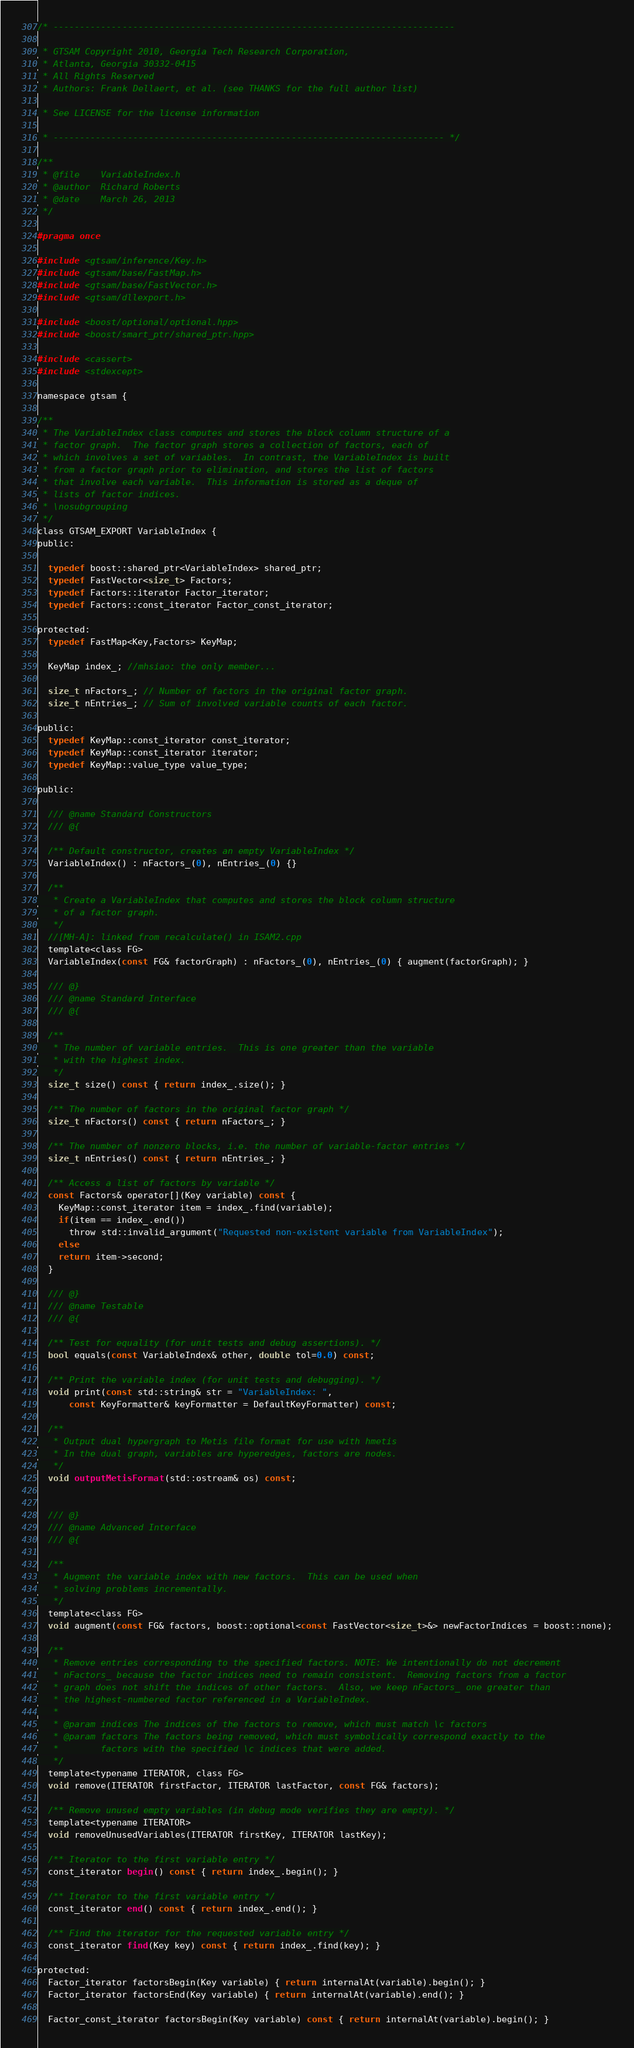Convert code to text. <code><loc_0><loc_0><loc_500><loc_500><_C_>/* ----------------------------------------------------------------------------

 * GTSAM Copyright 2010, Georgia Tech Research Corporation,
 * Atlanta, Georgia 30332-0415
 * All Rights Reserved
 * Authors: Frank Dellaert, et al. (see THANKS for the full author list)

 * See LICENSE for the license information

 * -------------------------------------------------------------------------- */

/**
 * @file    VariableIndex.h
 * @author  Richard Roberts
 * @date    March 26, 2013
 */

#pragma once

#include <gtsam/inference/Key.h>
#include <gtsam/base/FastMap.h>
#include <gtsam/base/FastVector.h>
#include <gtsam/dllexport.h>

#include <boost/optional/optional.hpp>
#include <boost/smart_ptr/shared_ptr.hpp>

#include <cassert>
#include <stdexcept>

namespace gtsam {

/**
 * The VariableIndex class computes and stores the block column structure of a
 * factor graph.  The factor graph stores a collection of factors, each of
 * which involves a set of variables.  In contrast, the VariableIndex is built
 * from a factor graph prior to elimination, and stores the list of factors
 * that involve each variable.  This information is stored as a deque of
 * lists of factor indices.
 * \nosubgrouping
 */
class GTSAM_EXPORT VariableIndex {
public:

  typedef boost::shared_ptr<VariableIndex> shared_ptr;
  typedef FastVector<size_t> Factors;
  typedef Factors::iterator Factor_iterator;
  typedef Factors::const_iterator Factor_const_iterator;

protected:
  typedef FastMap<Key,Factors> KeyMap;
  
  KeyMap index_; //mhsiao: the only member...
  
  size_t nFactors_; // Number of factors in the original factor graph.
  size_t nEntries_; // Sum of involved variable counts of each factor.

public:
  typedef KeyMap::const_iterator const_iterator;
  typedef KeyMap::const_iterator iterator;
  typedef KeyMap::value_type value_type;

public:

  /// @name Standard Constructors
  /// @{

  /** Default constructor, creates an empty VariableIndex */
  VariableIndex() : nFactors_(0), nEntries_(0) {}

  /**
   * Create a VariableIndex that computes and stores the block column structure
   * of a factor graph.
   */
  //[MH-A]: linked from recalculate() in ISAM2.cpp
  template<class FG>
  VariableIndex(const FG& factorGraph) : nFactors_(0), nEntries_(0) { augment(factorGraph); }

  /// @}
  /// @name Standard Interface
  /// @{

  /**
   * The number of variable entries.  This is one greater than the variable
   * with the highest index.
   */
  size_t size() const { return index_.size(); }

  /** The number of factors in the original factor graph */
  size_t nFactors() const { return nFactors_; }

  /** The number of nonzero blocks, i.e. the number of variable-factor entries */
  size_t nEntries() const { return nEntries_; }

  /** Access a list of factors by variable */
  const Factors& operator[](Key variable) const {
    KeyMap::const_iterator item = index_.find(variable);
    if(item == index_.end())
      throw std::invalid_argument("Requested non-existent variable from VariableIndex");
    else
    return item->second;
  }

  /// @}
  /// @name Testable
  /// @{

  /** Test for equality (for unit tests and debug assertions). */
  bool equals(const VariableIndex& other, double tol=0.0) const;

  /** Print the variable index (for unit tests and debugging). */
  void print(const std::string& str = "VariableIndex: ",
      const KeyFormatter& keyFormatter = DefaultKeyFormatter) const;

  /**
   * Output dual hypergraph to Metis file format for use with hmetis
   * In the dual graph, variables are hyperedges, factors are nodes.
   */
  void outputMetisFormat(std::ostream& os) const;


  /// @}
  /// @name Advanced Interface
  /// @{

  /**
   * Augment the variable index with new factors.  This can be used when
   * solving problems incrementally.
   */
  template<class FG>
  void augment(const FG& factors, boost::optional<const FastVector<size_t>&> newFactorIndices = boost::none);

  /**
   * Remove entries corresponding to the specified factors. NOTE: We intentionally do not decrement
   * nFactors_ because the factor indices need to remain consistent.  Removing factors from a factor
   * graph does not shift the indices of other factors.  Also, we keep nFactors_ one greater than
   * the highest-numbered factor referenced in a VariableIndex.
   *
   * @param indices The indices of the factors to remove, which must match \c factors
   * @param factors The factors being removed, which must symbolically correspond exactly to the
   *        factors with the specified \c indices that were added.
   */
  template<typename ITERATOR, class FG>
  void remove(ITERATOR firstFactor, ITERATOR lastFactor, const FG& factors);

  /** Remove unused empty variables (in debug mode verifies they are empty). */
  template<typename ITERATOR>
  void removeUnusedVariables(ITERATOR firstKey, ITERATOR lastKey);

  /** Iterator to the first variable entry */
  const_iterator begin() const { return index_.begin(); }

  /** Iterator to the first variable entry */
  const_iterator end() const { return index_.end(); }

  /** Find the iterator for the requested variable entry */
  const_iterator find(Key key) const { return index_.find(key); }

protected:
  Factor_iterator factorsBegin(Key variable) { return internalAt(variable).begin(); }
  Factor_iterator factorsEnd(Key variable) { return internalAt(variable).end(); }

  Factor_const_iterator factorsBegin(Key variable) const { return internalAt(variable).begin(); }</code> 